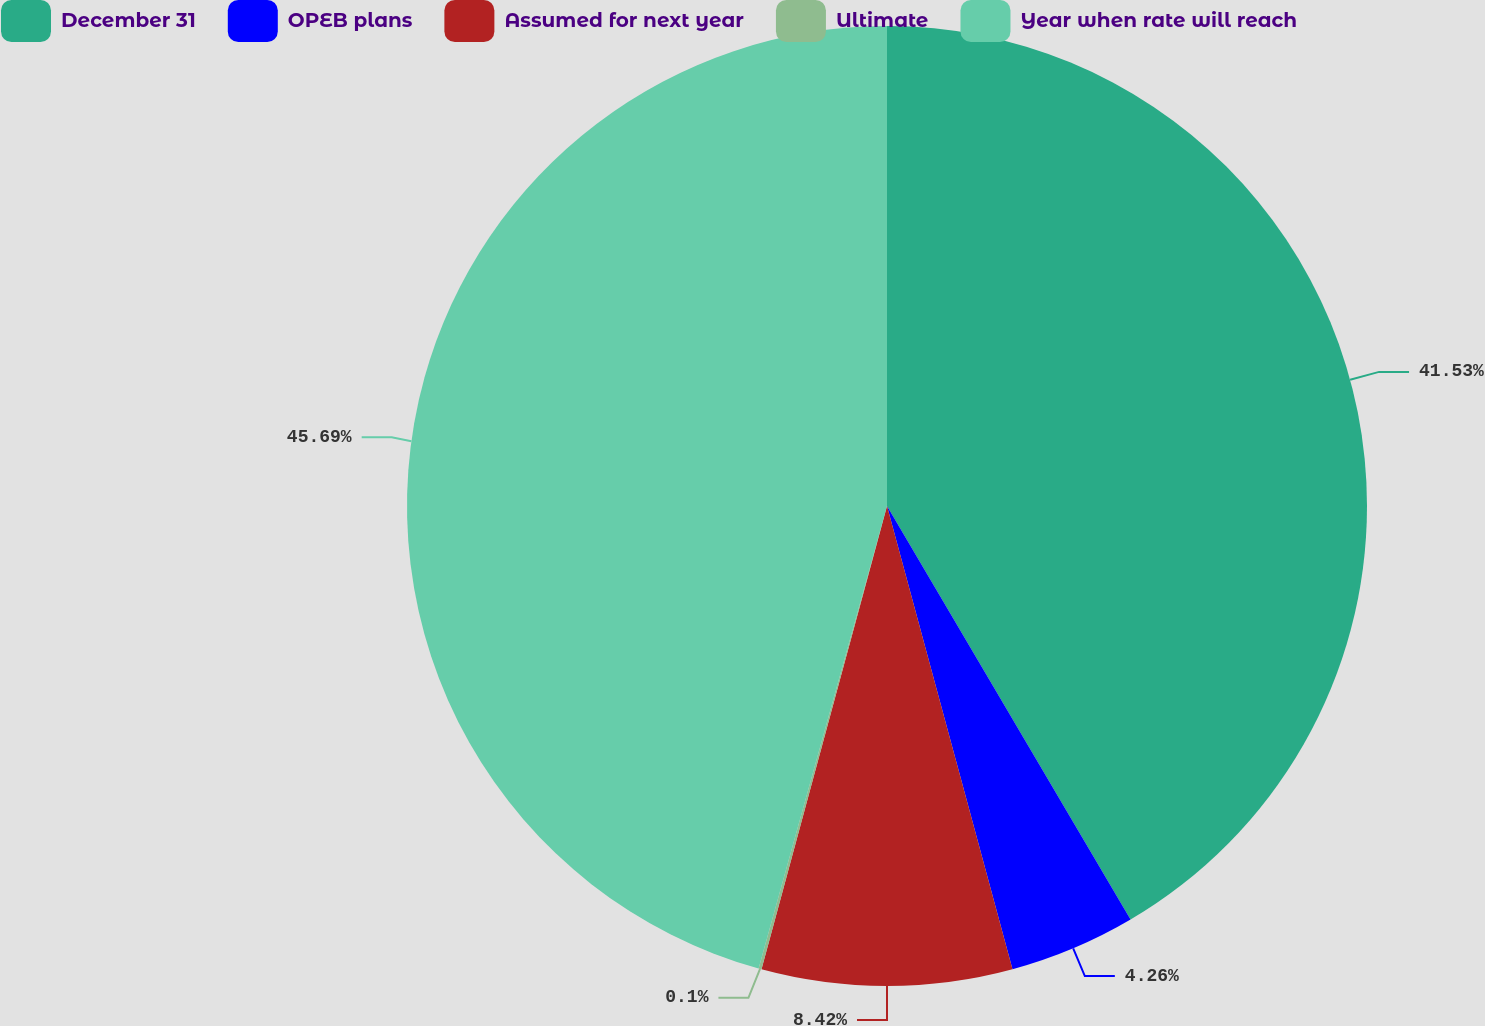Convert chart to OTSL. <chart><loc_0><loc_0><loc_500><loc_500><pie_chart><fcel>December 31<fcel>OPEB plans<fcel>Assumed for next year<fcel>Ultimate<fcel>Year when rate will reach<nl><fcel>41.53%<fcel>4.26%<fcel>8.42%<fcel>0.1%<fcel>45.69%<nl></chart> 